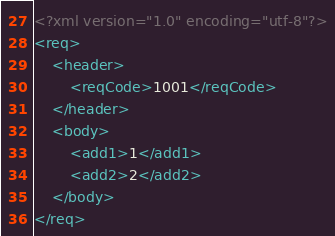Convert code to text. <code><loc_0><loc_0><loc_500><loc_500><_XML_><?xml version="1.0" encoding="utf-8"?>
<req>
	<header>
		<reqCode>1001</reqCode>
	</header>
	<body>
		<add1>1</add1>
		<add2>2</add2>
	</body>
</req></code> 